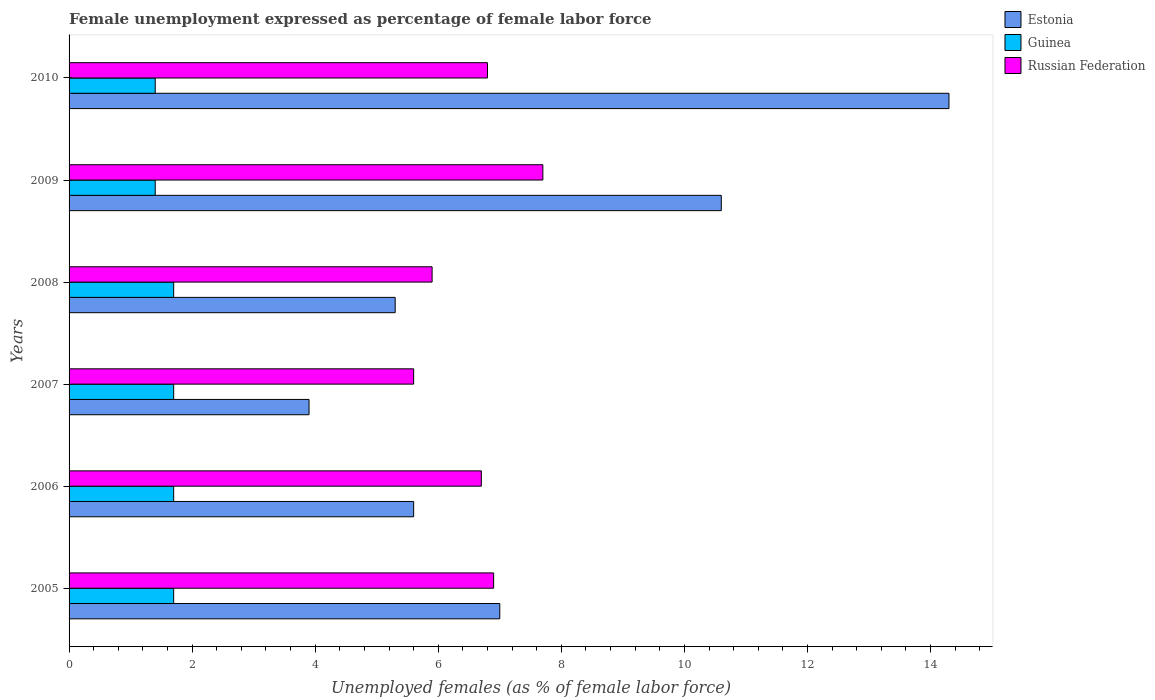Are the number of bars per tick equal to the number of legend labels?
Offer a terse response. Yes. What is the label of the 5th group of bars from the top?
Your answer should be very brief. 2006. In how many cases, is the number of bars for a given year not equal to the number of legend labels?
Your response must be concise. 0. What is the unemployment in females in in Russian Federation in 2007?
Ensure brevity in your answer.  5.6. Across all years, what is the maximum unemployment in females in in Estonia?
Provide a succinct answer. 14.3. Across all years, what is the minimum unemployment in females in in Estonia?
Provide a short and direct response. 3.9. In which year was the unemployment in females in in Estonia minimum?
Provide a succinct answer. 2007. What is the total unemployment in females in in Russian Federation in the graph?
Provide a short and direct response. 39.6. What is the difference between the unemployment in females in in Estonia in 2008 and that in 2010?
Provide a short and direct response. -9. What is the difference between the unemployment in females in in Estonia in 2005 and the unemployment in females in in Guinea in 2007?
Your answer should be very brief. 5.3. What is the average unemployment in females in in Estonia per year?
Your response must be concise. 7.78. In the year 2010, what is the difference between the unemployment in females in in Russian Federation and unemployment in females in in Guinea?
Provide a succinct answer. 5.4. What is the ratio of the unemployment in females in in Estonia in 2005 to that in 2008?
Provide a short and direct response. 1.32. Is the unemployment in females in in Guinea in 2005 less than that in 2006?
Offer a terse response. No. What is the difference between the highest and the second highest unemployment in females in in Russian Federation?
Keep it short and to the point. 0.8. What is the difference between the highest and the lowest unemployment in females in in Guinea?
Ensure brevity in your answer.  0.3. Is the sum of the unemployment in females in in Guinea in 2009 and 2010 greater than the maximum unemployment in females in in Estonia across all years?
Make the answer very short. No. What does the 2nd bar from the top in 2009 represents?
Give a very brief answer. Guinea. What does the 3rd bar from the bottom in 2010 represents?
Your response must be concise. Russian Federation. How many bars are there?
Your answer should be compact. 18. What is the difference between two consecutive major ticks on the X-axis?
Provide a succinct answer. 2. Are the values on the major ticks of X-axis written in scientific E-notation?
Provide a succinct answer. No. Does the graph contain any zero values?
Offer a terse response. No. What is the title of the graph?
Your answer should be compact. Female unemployment expressed as percentage of female labor force. What is the label or title of the X-axis?
Ensure brevity in your answer.  Unemployed females (as % of female labor force). What is the label or title of the Y-axis?
Give a very brief answer. Years. What is the Unemployed females (as % of female labor force) in Estonia in 2005?
Ensure brevity in your answer.  7. What is the Unemployed females (as % of female labor force) in Guinea in 2005?
Provide a succinct answer. 1.7. What is the Unemployed females (as % of female labor force) of Russian Federation in 2005?
Offer a very short reply. 6.9. What is the Unemployed females (as % of female labor force) in Estonia in 2006?
Offer a very short reply. 5.6. What is the Unemployed females (as % of female labor force) in Guinea in 2006?
Your answer should be very brief. 1.7. What is the Unemployed females (as % of female labor force) of Russian Federation in 2006?
Ensure brevity in your answer.  6.7. What is the Unemployed females (as % of female labor force) in Estonia in 2007?
Provide a short and direct response. 3.9. What is the Unemployed females (as % of female labor force) of Guinea in 2007?
Offer a terse response. 1.7. What is the Unemployed females (as % of female labor force) in Russian Federation in 2007?
Offer a terse response. 5.6. What is the Unemployed females (as % of female labor force) of Estonia in 2008?
Your answer should be compact. 5.3. What is the Unemployed females (as % of female labor force) in Guinea in 2008?
Make the answer very short. 1.7. What is the Unemployed females (as % of female labor force) in Russian Federation in 2008?
Offer a terse response. 5.9. What is the Unemployed females (as % of female labor force) of Estonia in 2009?
Make the answer very short. 10.6. What is the Unemployed females (as % of female labor force) in Guinea in 2009?
Provide a succinct answer. 1.4. What is the Unemployed females (as % of female labor force) of Russian Federation in 2009?
Your answer should be very brief. 7.7. What is the Unemployed females (as % of female labor force) of Estonia in 2010?
Your answer should be very brief. 14.3. What is the Unemployed females (as % of female labor force) of Guinea in 2010?
Offer a very short reply. 1.4. What is the Unemployed females (as % of female labor force) in Russian Federation in 2010?
Your answer should be very brief. 6.8. Across all years, what is the maximum Unemployed females (as % of female labor force) of Estonia?
Offer a very short reply. 14.3. Across all years, what is the maximum Unemployed females (as % of female labor force) in Guinea?
Offer a very short reply. 1.7. Across all years, what is the maximum Unemployed females (as % of female labor force) of Russian Federation?
Your answer should be very brief. 7.7. Across all years, what is the minimum Unemployed females (as % of female labor force) of Estonia?
Provide a short and direct response. 3.9. Across all years, what is the minimum Unemployed females (as % of female labor force) in Guinea?
Your answer should be compact. 1.4. Across all years, what is the minimum Unemployed females (as % of female labor force) of Russian Federation?
Keep it short and to the point. 5.6. What is the total Unemployed females (as % of female labor force) of Estonia in the graph?
Offer a terse response. 46.7. What is the total Unemployed females (as % of female labor force) of Russian Federation in the graph?
Your response must be concise. 39.6. What is the difference between the Unemployed females (as % of female labor force) of Estonia in 2005 and that in 2006?
Provide a short and direct response. 1.4. What is the difference between the Unemployed females (as % of female labor force) in Russian Federation in 2005 and that in 2006?
Provide a succinct answer. 0.2. What is the difference between the Unemployed females (as % of female labor force) of Guinea in 2005 and that in 2007?
Offer a terse response. 0. What is the difference between the Unemployed females (as % of female labor force) of Russian Federation in 2005 and that in 2007?
Keep it short and to the point. 1.3. What is the difference between the Unemployed females (as % of female labor force) of Estonia in 2005 and that in 2008?
Offer a very short reply. 1.7. What is the difference between the Unemployed females (as % of female labor force) in Guinea in 2005 and that in 2009?
Your response must be concise. 0.3. What is the difference between the Unemployed females (as % of female labor force) of Russian Federation in 2005 and that in 2009?
Offer a terse response. -0.8. What is the difference between the Unemployed females (as % of female labor force) of Estonia in 2005 and that in 2010?
Your answer should be very brief. -7.3. What is the difference between the Unemployed females (as % of female labor force) of Guinea in 2005 and that in 2010?
Your response must be concise. 0.3. What is the difference between the Unemployed females (as % of female labor force) of Guinea in 2006 and that in 2007?
Provide a short and direct response. 0. What is the difference between the Unemployed females (as % of female labor force) in Guinea in 2006 and that in 2008?
Provide a short and direct response. 0. What is the difference between the Unemployed females (as % of female labor force) of Guinea in 2006 and that in 2009?
Keep it short and to the point. 0.3. What is the difference between the Unemployed females (as % of female labor force) of Russian Federation in 2006 and that in 2009?
Offer a very short reply. -1. What is the difference between the Unemployed females (as % of female labor force) in Estonia in 2006 and that in 2010?
Your answer should be very brief. -8.7. What is the difference between the Unemployed females (as % of female labor force) of Guinea in 2006 and that in 2010?
Your answer should be very brief. 0.3. What is the difference between the Unemployed females (as % of female labor force) of Estonia in 2007 and that in 2008?
Provide a succinct answer. -1.4. What is the difference between the Unemployed females (as % of female labor force) in Guinea in 2007 and that in 2008?
Your answer should be very brief. 0. What is the difference between the Unemployed females (as % of female labor force) in Estonia in 2007 and that in 2009?
Your answer should be compact. -6.7. What is the difference between the Unemployed females (as % of female labor force) in Guinea in 2007 and that in 2009?
Offer a very short reply. 0.3. What is the difference between the Unemployed females (as % of female labor force) of Estonia in 2007 and that in 2010?
Your answer should be compact. -10.4. What is the difference between the Unemployed females (as % of female labor force) in Guinea in 2008 and that in 2009?
Provide a short and direct response. 0.3. What is the difference between the Unemployed females (as % of female labor force) in Russian Federation in 2008 and that in 2009?
Keep it short and to the point. -1.8. What is the difference between the Unemployed females (as % of female labor force) of Estonia in 2008 and that in 2010?
Ensure brevity in your answer.  -9. What is the difference between the Unemployed females (as % of female labor force) of Guinea in 2008 and that in 2010?
Your answer should be compact. 0.3. What is the difference between the Unemployed females (as % of female labor force) of Estonia in 2009 and that in 2010?
Offer a terse response. -3.7. What is the difference between the Unemployed females (as % of female labor force) in Guinea in 2009 and that in 2010?
Offer a very short reply. 0. What is the difference between the Unemployed females (as % of female labor force) in Russian Federation in 2009 and that in 2010?
Provide a short and direct response. 0.9. What is the difference between the Unemployed females (as % of female labor force) in Estonia in 2005 and the Unemployed females (as % of female labor force) in Guinea in 2006?
Give a very brief answer. 5.3. What is the difference between the Unemployed females (as % of female labor force) of Guinea in 2005 and the Unemployed females (as % of female labor force) of Russian Federation in 2006?
Your answer should be very brief. -5. What is the difference between the Unemployed females (as % of female labor force) of Estonia in 2005 and the Unemployed females (as % of female labor force) of Guinea in 2007?
Your answer should be very brief. 5.3. What is the difference between the Unemployed females (as % of female labor force) of Guinea in 2005 and the Unemployed females (as % of female labor force) of Russian Federation in 2007?
Provide a succinct answer. -3.9. What is the difference between the Unemployed females (as % of female labor force) of Estonia in 2005 and the Unemployed females (as % of female labor force) of Guinea in 2008?
Keep it short and to the point. 5.3. What is the difference between the Unemployed females (as % of female labor force) in Estonia in 2005 and the Unemployed females (as % of female labor force) in Russian Federation in 2008?
Your answer should be compact. 1.1. What is the difference between the Unemployed females (as % of female labor force) in Estonia in 2005 and the Unemployed females (as % of female labor force) in Guinea in 2009?
Offer a terse response. 5.6. What is the difference between the Unemployed females (as % of female labor force) in Guinea in 2005 and the Unemployed females (as % of female labor force) in Russian Federation in 2009?
Your answer should be compact. -6. What is the difference between the Unemployed females (as % of female labor force) of Estonia in 2005 and the Unemployed females (as % of female labor force) of Guinea in 2010?
Provide a succinct answer. 5.6. What is the difference between the Unemployed females (as % of female labor force) of Estonia in 2005 and the Unemployed females (as % of female labor force) of Russian Federation in 2010?
Offer a terse response. 0.2. What is the difference between the Unemployed females (as % of female labor force) of Guinea in 2005 and the Unemployed females (as % of female labor force) of Russian Federation in 2010?
Offer a very short reply. -5.1. What is the difference between the Unemployed females (as % of female labor force) in Estonia in 2006 and the Unemployed females (as % of female labor force) in Guinea in 2007?
Provide a succinct answer. 3.9. What is the difference between the Unemployed females (as % of female labor force) of Estonia in 2006 and the Unemployed females (as % of female labor force) of Russian Federation in 2007?
Make the answer very short. 0. What is the difference between the Unemployed females (as % of female labor force) of Guinea in 2006 and the Unemployed females (as % of female labor force) of Russian Federation in 2008?
Ensure brevity in your answer.  -4.2. What is the difference between the Unemployed females (as % of female labor force) in Guinea in 2006 and the Unemployed females (as % of female labor force) in Russian Federation in 2010?
Make the answer very short. -5.1. What is the difference between the Unemployed females (as % of female labor force) in Estonia in 2007 and the Unemployed females (as % of female labor force) in Guinea in 2009?
Provide a short and direct response. 2.5. What is the difference between the Unemployed females (as % of female labor force) of Estonia in 2007 and the Unemployed females (as % of female labor force) of Russian Federation in 2009?
Give a very brief answer. -3.8. What is the difference between the Unemployed females (as % of female labor force) of Guinea in 2007 and the Unemployed females (as % of female labor force) of Russian Federation in 2009?
Your answer should be compact. -6. What is the difference between the Unemployed females (as % of female labor force) in Estonia in 2007 and the Unemployed females (as % of female labor force) in Guinea in 2010?
Your response must be concise. 2.5. What is the difference between the Unemployed females (as % of female labor force) in Estonia in 2007 and the Unemployed females (as % of female labor force) in Russian Federation in 2010?
Give a very brief answer. -2.9. What is the difference between the Unemployed females (as % of female labor force) of Estonia in 2008 and the Unemployed females (as % of female labor force) of Guinea in 2009?
Offer a very short reply. 3.9. What is the difference between the Unemployed females (as % of female labor force) of Estonia in 2008 and the Unemployed females (as % of female labor force) of Russian Federation in 2009?
Your answer should be very brief. -2.4. What is the difference between the Unemployed females (as % of female labor force) in Estonia in 2008 and the Unemployed females (as % of female labor force) in Guinea in 2010?
Offer a very short reply. 3.9. What is the difference between the Unemployed females (as % of female labor force) of Estonia in 2008 and the Unemployed females (as % of female labor force) of Russian Federation in 2010?
Keep it short and to the point. -1.5. What is the difference between the Unemployed females (as % of female labor force) of Estonia in 2009 and the Unemployed females (as % of female labor force) of Guinea in 2010?
Provide a short and direct response. 9.2. What is the average Unemployed females (as % of female labor force) in Estonia per year?
Ensure brevity in your answer.  7.78. What is the average Unemployed females (as % of female labor force) in Russian Federation per year?
Give a very brief answer. 6.6. In the year 2005, what is the difference between the Unemployed females (as % of female labor force) of Estonia and Unemployed females (as % of female labor force) of Russian Federation?
Your answer should be compact. 0.1. In the year 2005, what is the difference between the Unemployed females (as % of female labor force) in Guinea and Unemployed females (as % of female labor force) in Russian Federation?
Offer a terse response. -5.2. In the year 2006, what is the difference between the Unemployed females (as % of female labor force) of Estonia and Unemployed females (as % of female labor force) of Guinea?
Give a very brief answer. 3.9. In the year 2006, what is the difference between the Unemployed females (as % of female labor force) in Guinea and Unemployed females (as % of female labor force) in Russian Federation?
Keep it short and to the point. -5. In the year 2008, what is the difference between the Unemployed females (as % of female labor force) in Estonia and Unemployed females (as % of female labor force) in Guinea?
Your response must be concise. 3.6. In the year 2008, what is the difference between the Unemployed females (as % of female labor force) of Estonia and Unemployed females (as % of female labor force) of Russian Federation?
Ensure brevity in your answer.  -0.6. In the year 2009, what is the difference between the Unemployed females (as % of female labor force) of Estonia and Unemployed females (as % of female labor force) of Russian Federation?
Provide a succinct answer. 2.9. In the year 2009, what is the difference between the Unemployed females (as % of female labor force) of Guinea and Unemployed females (as % of female labor force) of Russian Federation?
Ensure brevity in your answer.  -6.3. In the year 2010, what is the difference between the Unemployed females (as % of female labor force) of Estonia and Unemployed females (as % of female labor force) of Guinea?
Keep it short and to the point. 12.9. What is the ratio of the Unemployed females (as % of female labor force) of Russian Federation in 2005 to that in 2006?
Your response must be concise. 1.03. What is the ratio of the Unemployed females (as % of female labor force) in Estonia in 2005 to that in 2007?
Your answer should be compact. 1.79. What is the ratio of the Unemployed females (as % of female labor force) of Guinea in 2005 to that in 2007?
Provide a succinct answer. 1. What is the ratio of the Unemployed females (as % of female labor force) of Russian Federation in 2005 to that in 2007?
Provide a succinct answer. 1.23. What is the ratio of the Unemployed females (as % of female labor force) in Estonia in 2005 to that in 2008?
Provide a short and direct response. 1.32. What is the ratio of the Unemployed females (as % of female labor force) in Guinea in 2005 to that in 2008?
Give a very brief answer. 1. What is the ratio of the Unemployed females (as % of female labor force) in Russian Federation in 2005 to that in 2008?
Provide a succinct answer. 1.17. What is the ratio of the Unemployed females (as % of female labor force) of Estonia in 2005 to that in 2009?
Your answer should be very brief. 0.66. What is the ratio of the Unemployed females (as % of female labor force) of Guinea in 2005 to that in 2009?
Your answer should be very brief. 1.21. What is the ratio of the Unemployed females (as % of female labor force) of Russian Federation in 2005 to that in 2009?
Your response must be concise. 0.9. What is the ratio of the Unemployed females (as % of female labor force) of Estonia in 2005 to that in 2010?
Keep it short and to the point. 0.49. What is the ratio of the Unemployed females (as % of female labor force) of Guinea in 2005 to that in 2010?
Provide a short and direct response. 1.21. What is the ratio of the Unemployed females (as % of female labor force) of Russian Federation in 2005 to that in 2010?
Make the answer very short. 1.01. What is the ratio of the Unemployed females (as % of female labor force) of Estonia in 2006 to that in 2007?
Make the answer very short. 1.44. What is the ratio of the Unemployed females (as % of female labor force) of Russian Federation in 2006 to that in 2007?
Ensure brevity in your answer.  1.2. What is the ratio of the Unemployed females (as % of female labor force) in Estonia in 2006 to that in 2008?
Your answer should be compact. 1.06. What is the ratio of the Unemployed females (as % of female labor force) of Guinea in 2006 to that in 2008?
Your response must be concise. 1. What is the ratio of the Unemployed females (as % of female labor force) in Russian Federation in 2006 to that in 2008?
Offer a very short reply. 1.14. What is the ratio of the Unemployed females (as % of female labor force) of Estonia in 2006 to that in 2009?
Provide a short and direct response. 0.53. What is the ratio of the Unemployed females (as % of female labor force) of Guinea in 2006 to that in 2009?
Provide a short and direct response. 1.21. What is the ratio of the Unemployed females (as % of female labor force) of Russian Federation in 2006 to that in 2009?
Offer a terse response. 0.87. What is the ratio of the Unemployed females (as % of female labor force) of Estonia in 2006 to that in 2010?
Ensure brevity in your answer.  0.39. What is the ratio of the Unemployed females (as % of female labor force) in Guinea in 2006 to that in 2010?
Your answer should be compact. 1.21. What is the ratio of the Unemployed females (as % of female labor force) of Russian Federation in 2006 to that in 2010?
Provide a succinct answer. 0.99. What is the ratio of the Unemployed females (as % of female labor force) of Estonia in 2007 to that in 2008?
Make the answer very short. 0.74. What is the ratio of the Unemployed females (as % of female labor force) of Guinea in 2007 to that in 2008?
Offer a very short reply. 1. What is the ratio of the Unemployed females (as % of female labor force) in Russian Federation in 2007 to that in 2008?
Your response must be concise. 0.95. What is the ratio of the Unemployed females (as % of female labor force) of Estonia in 2007 to that in 2009?
Keep it short and to the point. 0.37. What is the ratio of the Unemployed females (as % of female labor force) in Guinea in 2007 to that in 2009?
Give a very brief answer. 1.21. What is the ratio of the Unemployed females (as % of female labor force) in Russian Federation in 2007 to that in 2009?
Provide a succinct answer. 0.73. What is the ratio of the Unemployed females (as % of female labor force) in Estonia in 2007 to that in 2010?
Your answer should be compact. 0.27. What is the ratio of the Unemployed females (as % of female labor force) of Guinea in 2007 to that in 2010?
Your answer should be very brief. 1.21. What is the ratio of the Unemployed females (as % of female labor force) in Russian Federation in 2007 to that in 2010?
Your answer should be compact. 0.82. What is the ratio of the Unemployed females (as % of female labor force) of Guinea in 2008 to that in 2009?
Your answer should be compact. 1.21. What is the ratio of the Unemployed females (as % of female labor force) of Russian Federation in 2008 to that in 2009?
Ensure brevity in your answer.  0.77. What is the ratio of the Unemployed females (as % of female labor force) in Estonia in 2008 to that in 2010?
Give a very brief answer. 0.37. What is the ratio of the Unemployed females (as % of female labor force) in Guinea in 2008 to that in 2010?
Offer a terse response. 1.21. What is the ratio of the Unemployed females (as % of female labor force) of Russian Federation in 2008 to that in 2010?
Keep it short and to the point. 0.87. What is the ratio of the Unemployed females (as % of female labor force) of Estonia in 2009 to that in 2010?
Provide a succinct answer. 0.74. What is the ratio of the Unemployed females (as % of female labor force) in Guinea in 2009 to that in 2010?
Your answer should be very brief. 1. What is the ratio of the Unemployed females (as % of female labor force) of Russian Federation in 2009 to that in 2010?
Give a very brief answer. 1.13. What is the difference between the highest and the second highest Unemployed females (as % of female labor force) of Guinea?
Offer a terse response. 0. What is the difference between the highest and the second highest Unemployed females (as % of female labor force) of Russian Federation?
Provide a short and direct response. 0.8. What is the difference between the highest and the lowest Unemployed females (as % of female labor force) of Estonia?
Your response must be concise. 10.4. 